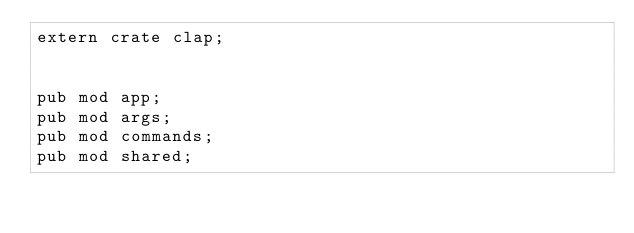<code> <loc_0><loc_0><loc_500><loc_500><_Rust_>extern crate clap;


pub mod app;
pub mod args;
pub mod commands;
pub mod shared;
</code> 